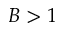Convert formula to latex. <formula><loc_0><loc_0><loc_500><loc_500>B > 1</formula> 